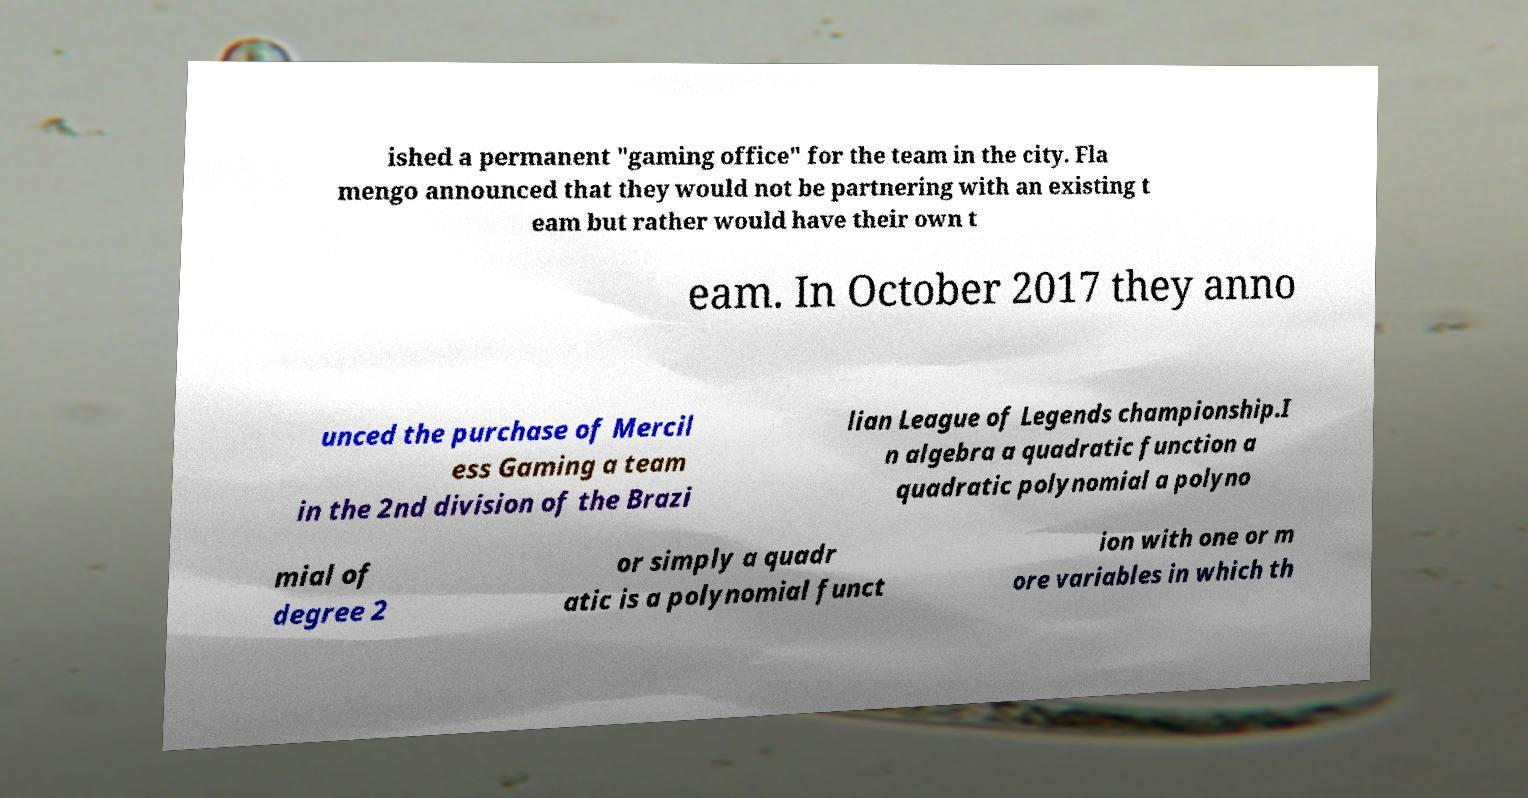There's text embedded in this image that I need extracted. Can you transcribe it verbatim? ished a permanent "gaming office" for the team in the city. Fla mengo announced that they would not be partnering with an existing t eam but rather would have their own t eam. In October 2017 they anno unced the purchase of Mercil ess Gaming a team in the 2nd division of the Brazi lian League of Legends championship.I n algebra a quadratic function a quadratic polynomial a polyno mial of degree 2 or simply a quadr atic is a polynomial funct ion with one or m ore variables in which th 